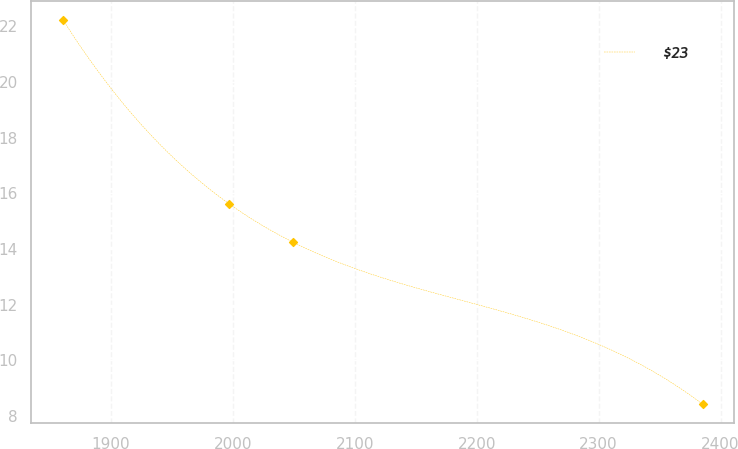Convert chart. <chart><loc_0><loc_0><loc_500><loc_500><line_chart><ecel><fcel>$23<nl><fcel>1860.89<fcel>22.22<nl><fcel>1996.96<fcel>15.62<nl><fcel>2049.39<fcel>14.24<nl><fcel>2385.17<fcel>8.42<nl></chart> 